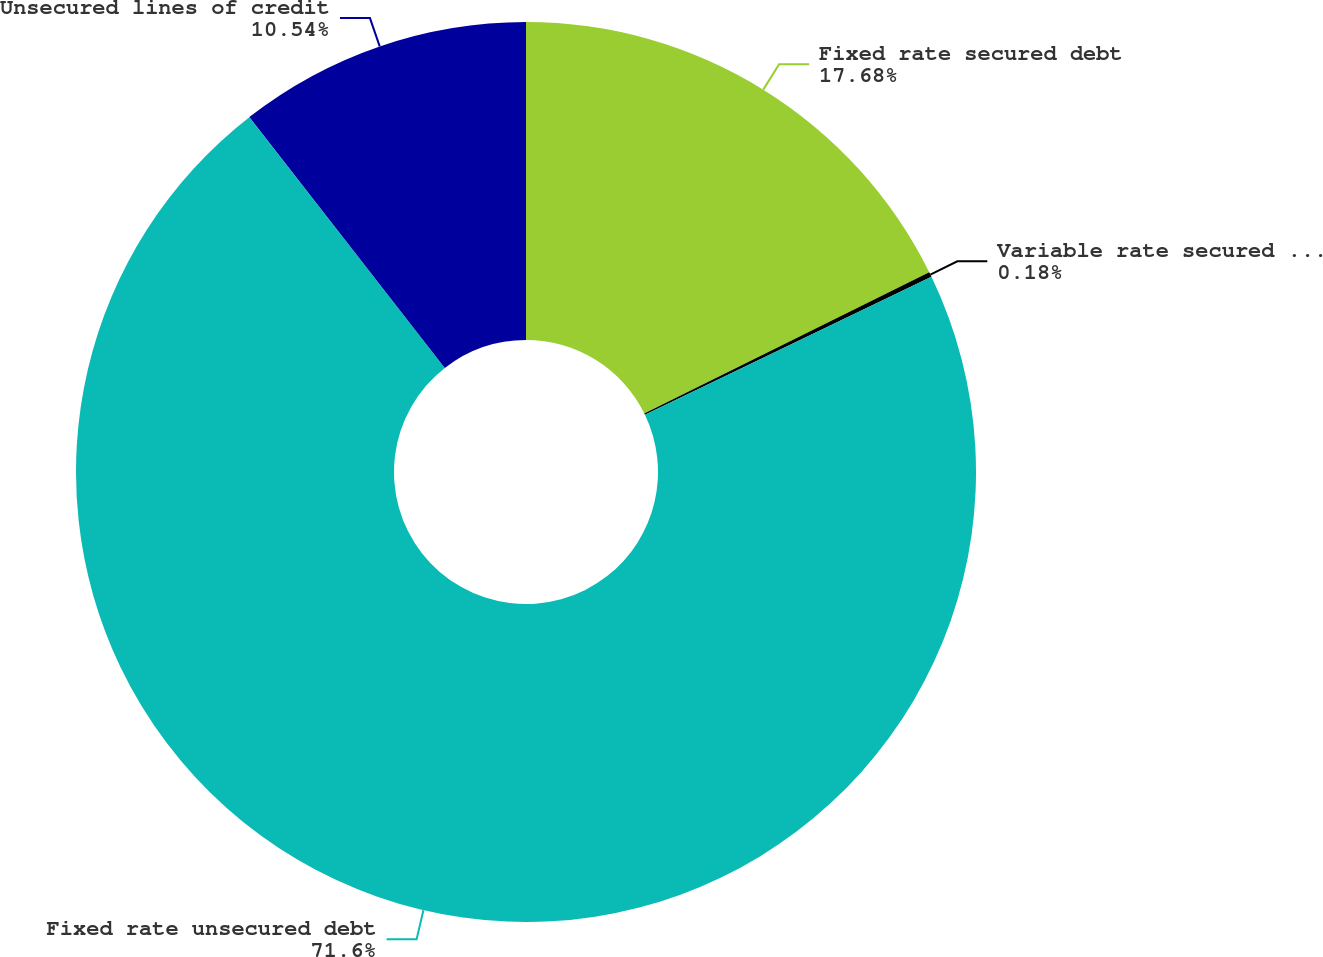Convert chart. <chart><loc_0><loc_0><loc_500><loc_500><pie_chart><fcel>Fixed rate secured debt<fcel>Variable rate secured debt<fcel>Fixed rate unsecured debt<fcel>Unsecured lines of credit<nl><fcel>17.68%<fcel>0.18%<fcel>71.6%<fcel>10.54%<nl></chart> 